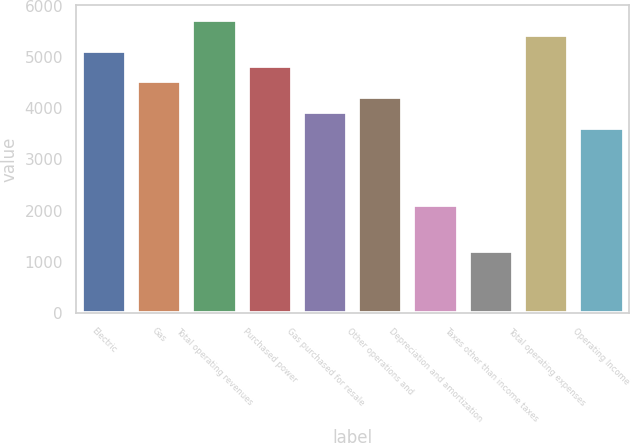Convert chart to OTSL. <chart><loc_0><loc_0><loc_500><loc_500><bar_chart><fcel>Electric<fcel>Gas<fcel>Total operating revenues<fcel>Purchased power<fcel>Gas purchased for resale<fcel>Other operations and<fcel>Depreciation and amortization<fcel>Taxes other than income taxes<fcel>Total operating expenses<fcel>Operating Income<nl><fcel>5121<fcel>4519<fcel>5723<fcel>4820<fcel>3917<fcel>4218<fcel>2111<fcel>1208<fcel>5422<fcel>3616<nl></chart> 